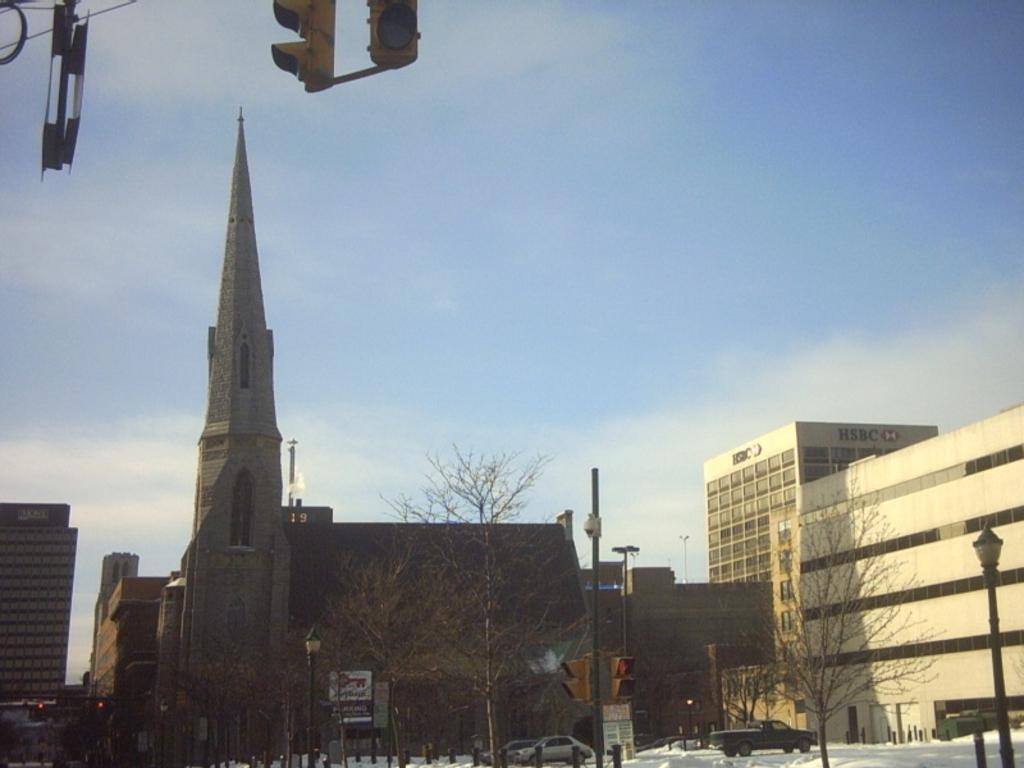Describe this image in one or two sentences. In this picture I can see the church, buildings, trees and street lights. At the bottom I can see some cars on the road, beside them it might be the snow on the road. In the top left I can see the traffic signals, electric wires and other objects. In the top left I can see the sky and clouds. 